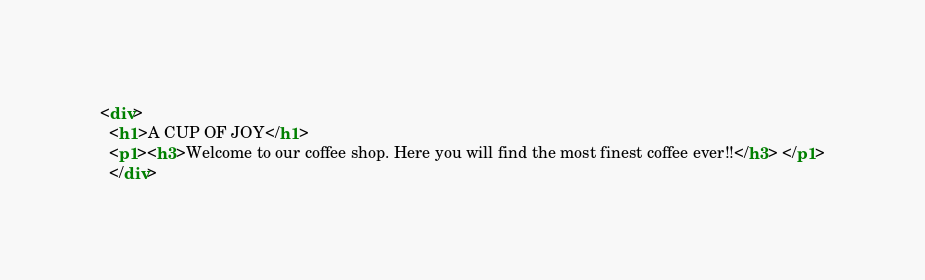Convert code to text. <code><loc_0><loc_0><loc_500><loc_500><_HTML_><div>
  <h1>A CUP OF JOY</h1>
  <p1><h3>Welcome to our coffee shop. Here you will find the most finest coffee ever!!</h3> </p1>
  </div></code> 